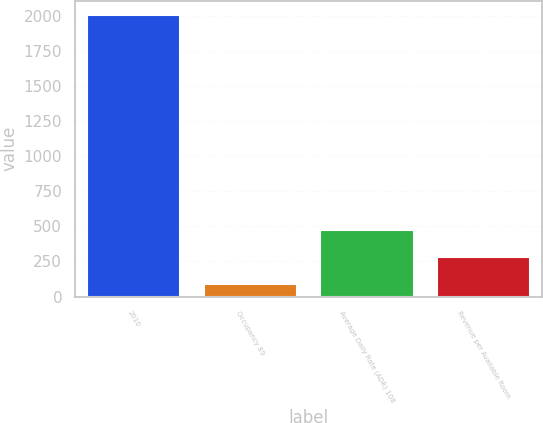<chart> <loc_0><loc_0><loc_500><loc_500><bar_chart><fcel>2010<fcel>Occupancy 89<fcel>Average Daily Rate (ADR) 108<fcel>Revenue per Available Room<nl><fcel>2008<fcel>92<fcel>475.2<fcel>283.6<nl></chart> 